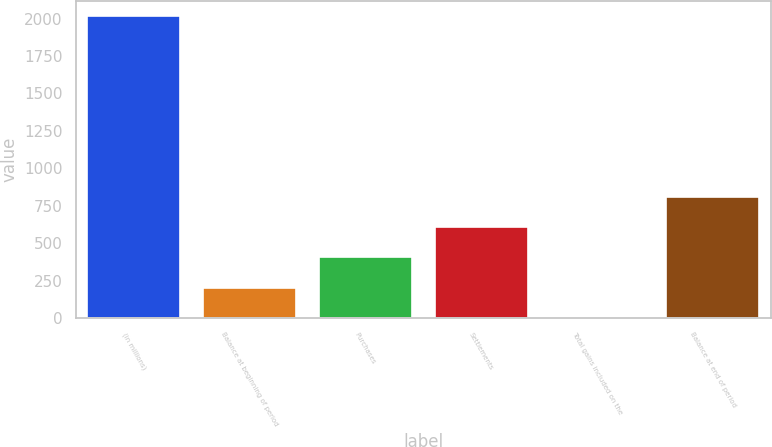<chart> <loc_0><loc_0><loc_500><loc_500><bar_chart><fcel>(in millions)<fcel>Balance at beginning of period<fcel>Purchases<fcel>Settlements<fcel>Total gains included on the<fcel>Balance at end of period<nl><fcel>2016<fcel>203.4<fcel>404.8<fcel>606.2<fcel>2<fcel>807.6<nl></chart> 